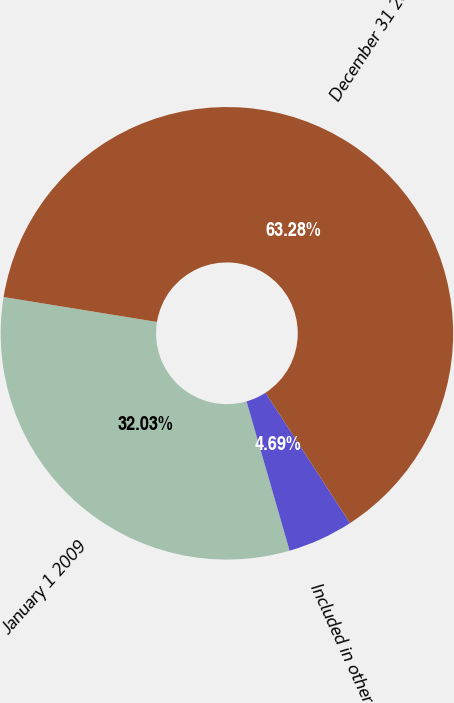<chart> <loc_0><loc_0><loc_500><loc_500><pie_chart><fcel>January 1 2009<fcel>Included in other<fcel>December 31 2009<nl><fcel>32.03%<fcel>4.69%<fcel>63.27%<nl></chart> 